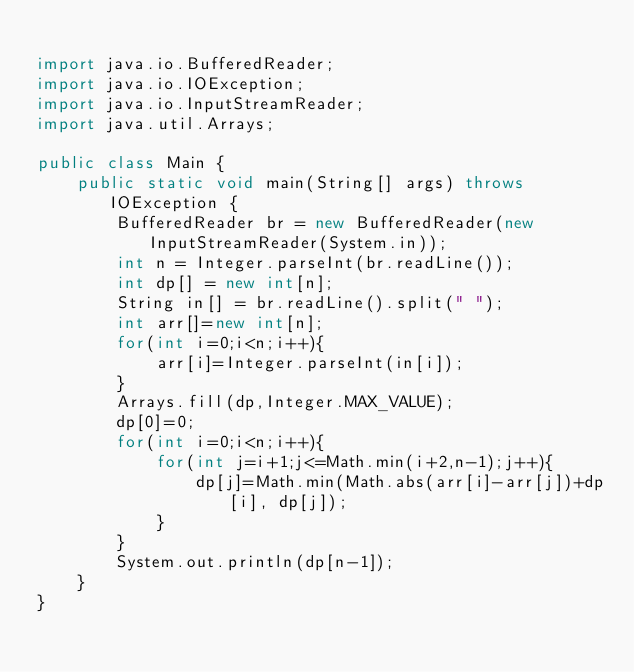Convert code to text. <code><loc_0><loc_0><loc_500><loc_500><_Java_>
import java.io.BufferedReader;
import java.io.IOException;
import java.io.InputStreamReader;
import java.util.Arrays;

public class Main {
    public static void main(String[] args) throws IOException {
        BufferedReader br = new BufferedReader(new InputStreamReader(System.in));
        int n = Integer.parseInt(br.readLine());
        int dp[] = new int[n];
        String in[] = br.readLine().split(" ");
        int arr[]=new int[n];
        for(int i=0;i<n;i++){
            arr[i]=Integer.parseInt(in[i]);
        }
        Arrays.fill(dp,Integer.MAX_VALUE);
        dp[0]=0;
        for(int i=0;i<n;i++){
            for(int j=i+1;j<=Math.min(i+2,n-1);j++){
                dp[j]=Math.min(Math.abs(arr[i]-arr[j])+dp[i], dp[j]);
            }
        }
        System.out.println(dp[n-1]);
    }
}
</code> 